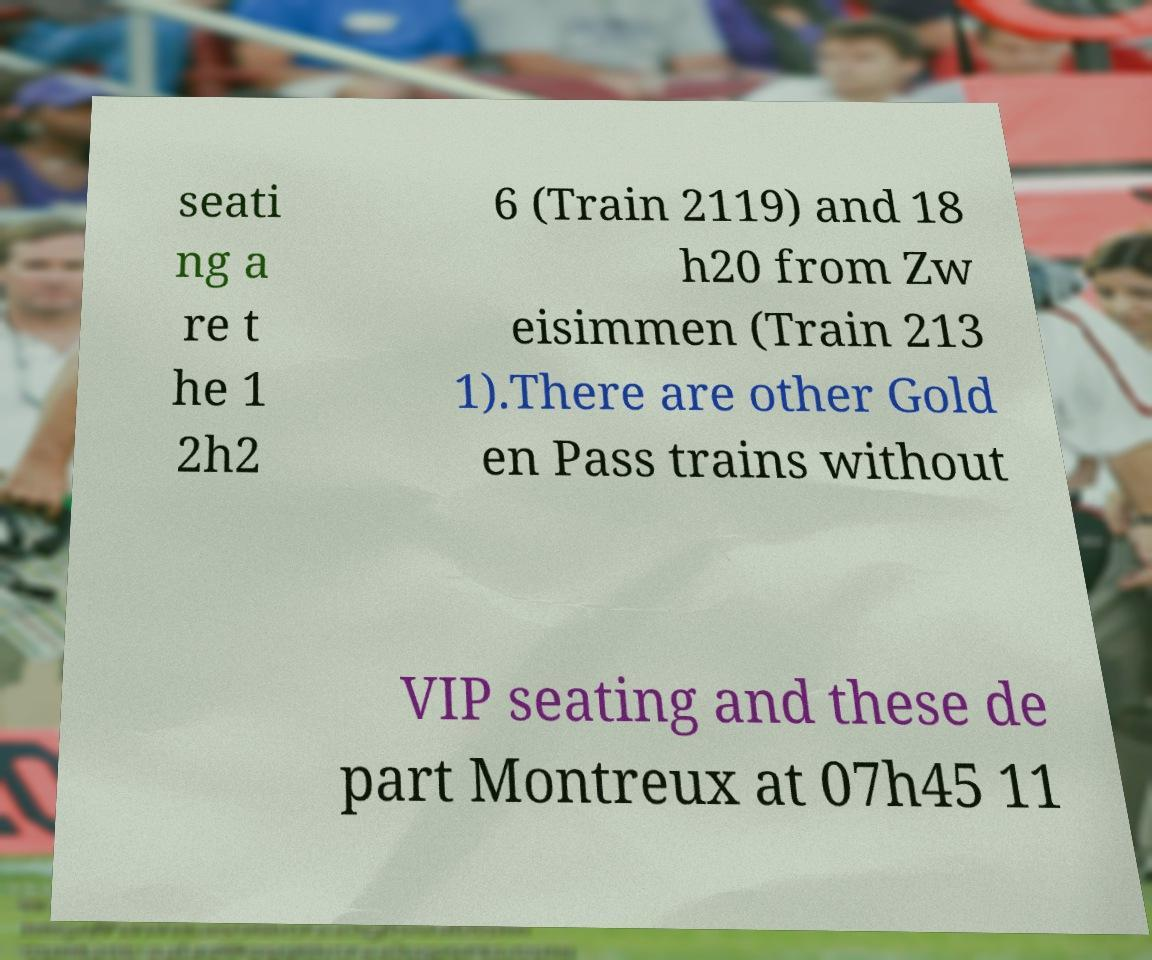Can you accurately transcribe the text from the provided image for me? seati ng a re t he 1 2h2 6 (Train 2119) and 18 h20 from Zw eisimmen (Train 213 1).There are other Gold en Pass trains without VIP seating and these de part Montreux at 07h45 11 